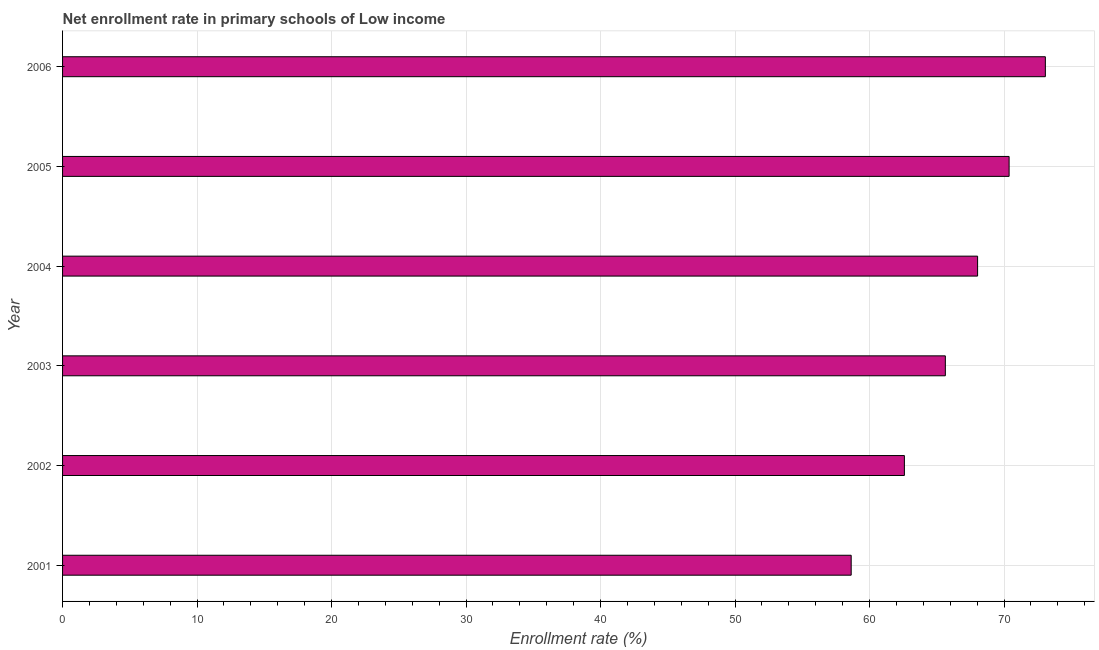Does the graph contain grids?
Ensure brevity in your answer.  Yes. What is the title of the graph?
Keep it short and to the point. Net enrollment rate in primary schools of Low income. What is the label or title of the X-axis?
Your response must be concise. Enrollment rate (%). What is the label or title of the Y-axis?
Keep it short and to the point. Year. What is the net enrollment rate in primary schools in 2004?
Provide a succinct answer. 68.03. Across all years, what is the maximum net enrollment rate in primary schools?
Give a very brief answer. 73.07. Across all years, what is the minimum net enrollment rate in primary schools?
Your answer should be compact. 58.63. In which year was the net enrollment rate in primary schools minimum?
Offer a very short reply. 2001. What is the sum of the net enrollment rate in primary schools?
Make the answer very short. 398.33. What is the difference between the net enrollment rate in primary schools in 2002 and 2005?
Your answer should be compact. -7.79. What is the average net enrollment rate in primary schools per year?
Your answer should be compact. 66.39. What is the median net enrollment rate in primary schools?
Make the answer very short. 66.83. What is the ratio of the net enrollment rate in primary schools in 2002 to that in 2005?
Make the answer very short. 0.89. Is the net enrollment rate in primary schools in 2001 less than that in 2004?
Make the answer very short. Yes. Is the difference between the net enrollment rate in primary schools in 2003 and 2004 greater than the difference between any two years?
Offer a very short reply. No. What is the difference between the highest and the second highest net enrollment rate in primary schools?
Provide a short and direct response. 2.69. Is the sum of the net enrollment rate in primary schools in 2001 and 2005 greater than the maximum net enrollment rate in primary schools across all years?
Your answer should be compact. Yes. What is the difference between the highest and the lowest net enrollment rate in primary schools?
Your answer should be very brief. 14.44. How many bars are there?
Your response must be concise. 6. Are all the bars in the graph horizontal?
Provide a short and direct response. Yes. What is the Enrollment rate (%) in 2001?
Provide a succinct answer. 58.63. What is the Enrollment rate (%) of 2002?
Offer a terse response. 62.59. What is the Enrollment rate (%) of 2003?
Provide a succinct answer. 65.63. What is the Enrollment rate (%) in 2004?
Offer a very short reply. 68.03. What is the Enrollment rate (%) of 2005?
Keep it short and to the point. 70.37. What is the Enrollment rate (%) of 2006?
Your answer should be compact. 73.07. What is the difference between the Enrollment rate (%) in 2001 and 2002?
Give a very brief answer. -3.96. What is the difference between the Enrollment rate (%) in 2001 and 2003?
Offer a very short reply. -7. What is the difference between the Enrollment rate (%) in 2001 and 2004?
Keep it short and to the point. -9.4. What is the difference between the Enrollment rate (%) in 2001 and 2005?
Offer a very short reply. -11.74. What is the difference between the Enrollment rate (%) in 2001 and 2006?
Your response must be concise. -14.44. What is the difference between the Enrollment rate (%) in 2002 and 2003?
Provide a succinct answer. -3.04. What is the difference between the Enrollment rate (%) in 2002 and 2004?
Keep it short and to the point. -5.44. What is the difference between the Enrollment rate (%) in 2002 and 2005?
Make the answer very short. -7.79. What is the difference between the Enrollment rate (%) in 2002 and 2006?
Offer a very short reply. -10.48. What is the difference between the Enrollment rate (%) in 2003 and 2004?
Ensure brevity in your answer.  -2.4. What is the difference between the Enrollment rate (%) in 2003 and 2005?
Give a very brief answer. -4.74. What is the difference between the Enrollment rate (%) in 2003 and 2006?
Your answer should be very brief. -7.44. What is the difference between the Enrollment rate (%) in 2004 and 2005?
Keep it short and to the point. -2.34. What is the difference between the Enrollment rate (%) in 2004 and 2006?
Your answer should be compact. -5.04. What is the difference between the Enrollment rate (%) in 2005 and 2006?
Make the answer very short. -2.69. What is the ratio of the Enrollment rate (%) in 2001 to that in 2002?
Provide a succinct answer. 0.94. What is the ratio of the Enrollment rate (%) in 2001 to that in 2003?
Your answer should be compact. 0.89. What is the ratio of the Enrollment rate (%) in 2001 to that in 2004?
Your answer should be compact. 0.86. What is the ratio of the Enrollment rate (%) in 2001 to that in 2005?
Provide a short and direct response. 0.83. What is the ratio of the Enrollment rate (%) in 2001 to that in 2006?
Your answer should be very brief. 0.8. What is the ratio of the Enrollment rate (%) in 2002 to that in 2003?
Provide a succinct answer. 0.95. What is the ratio of the Enrollment rate (%) in 2002 to that in 2004?
Give a very brief answer. 0.92. What is the ratio of the Enrollment rate (%) in 2002 to that in 2005?
Your answer should be compact. 0.89. What is the ratio of the Enrollment rate (%) in 2002 to that in 2006?
Give a very brief answer. 0.86. What is the ratio of the Enrollment rate (%) in 2003 to that in 2005?
Ensure brevity in your answer.  0.93. What is the ratio of the Enrollment rate (%) in 2003 to that in 2006?
Ensure brevity in your answer.  0.9. What is the ratio of the Enrollment rate (%) in 2004 to that in 2005?
Your answer should be very brief. 0.97. What is the ratio of the Enrollment rate (%) in 2004 to that in 2006?
Offer a very short reply. 0.93. 